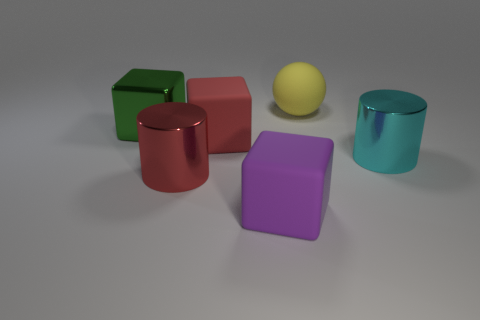Add 3 big green metallic cubes. How many objects exist? 9 Subtract all balls. How many objects are left? 5 Subtract all large red shiny cylinders. Subtract all big shiny cylinders. How many objects are left? 3 Add 2 big purple cubes. How many big purple cubes are left? 3 Add 5 big yellow metal spheres. How many big yellow metal spheres exist? 5 Subtract 0 blue spheres. How many objects are left? 6 